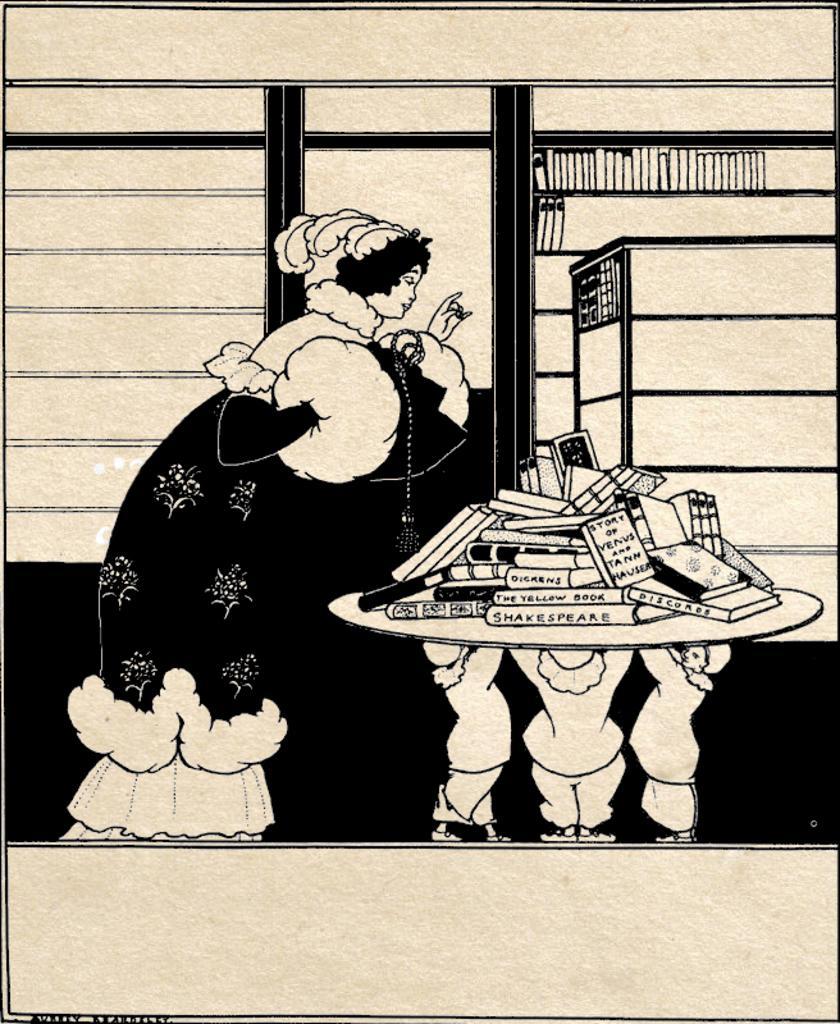Can you describe this image briefly? This is a sketch. On the left side of the image we can see a lady is bending and wearing a costume. On the right side of the image we can see a table. On the table we can see the books. In the background of the image we can see the wall. In the bottom left corner we can see the text. 